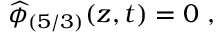Convert formula to latex. <formula><loc_0><loc_0><loc_500><loc_500>\widehat { \phi } _ { ( 5 / 3 ) } ( z , t ) = 0 \ ,</formula> 